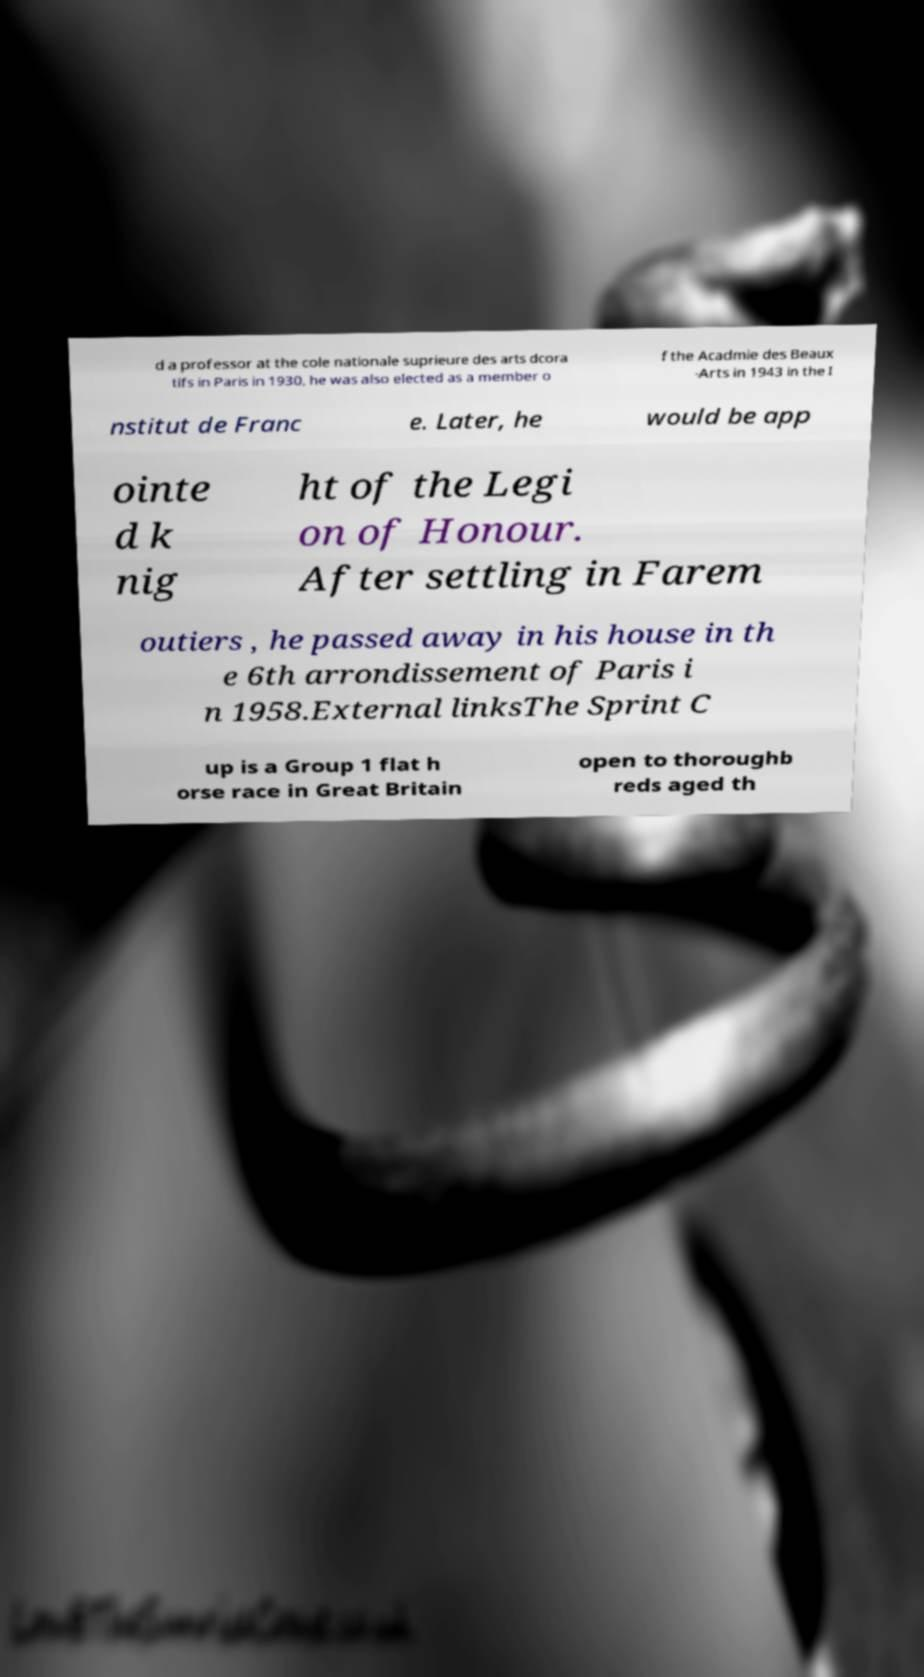Please read and relay the text visible in this image. What does it say? d a professor at the cole nationale suprieure des arts dcora tifs in Paris in 1930, he was also elected as a member o f the Acadmie des Beaux -Arts in 1943 in the I nstitut de Franc e. Later, he would be app ointe d k nig ht of the Legi on of Honour. After settling in Farem outiers , he passed away in his house in th e 6th arrondissement of Paris i n 1958.External linksThe Sprint C up is a Group 1 flat h orse race in Great Britain open to thoroughb reds aged th 